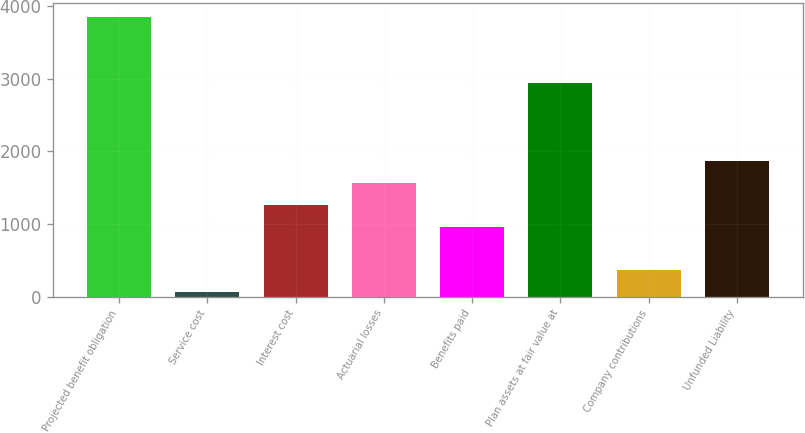<chart> <loc_0><loc_0><loc_500><loc_500><bar_chart><fcel>Projected benefit obligation<fcel>Service cost<fcel>Interest cost<fcel>Actuarial losses<fcel>Benefits paid<fcel>Plan assets at fair value at<fcel>Company contributions<fcel>Unfunded Liability<nl><fcel>3840.6<fcel>59<fcel>1264.6<fcel>1566<fcel>963.2<fcel>2936.4<fcel>360.4<fcel>1867.4<nl></chart> 